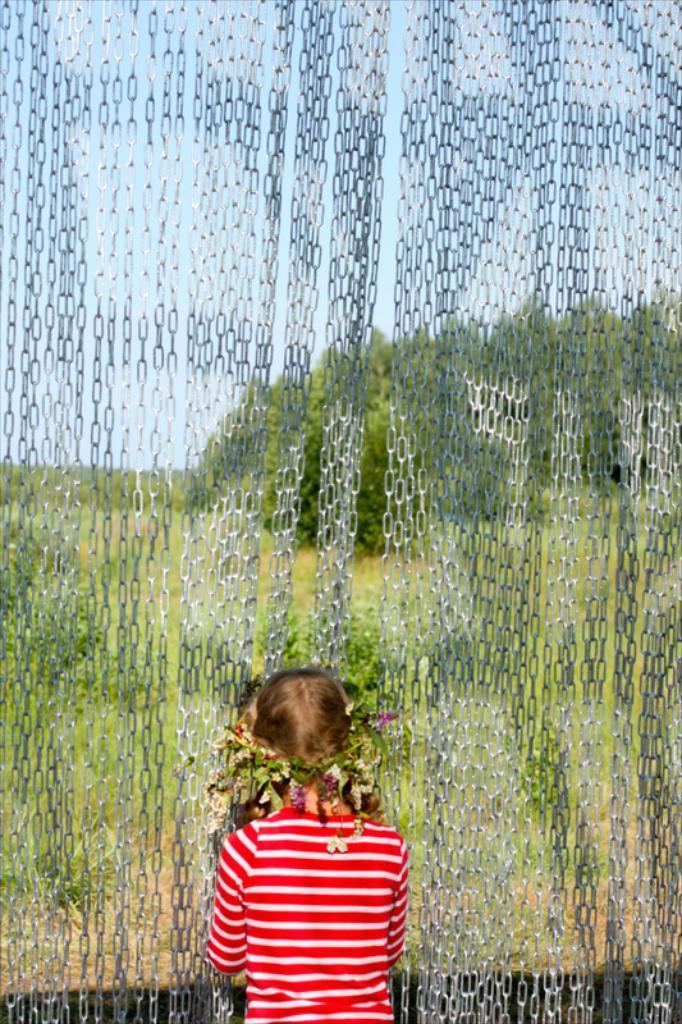Please provide a concise description of this image. In this image I can see a person wearing red and white t shirt is standing and I can see few leaves and few flowers to her head. I can see few metal chains and in the background I can see few trees, some grass and the sky. 